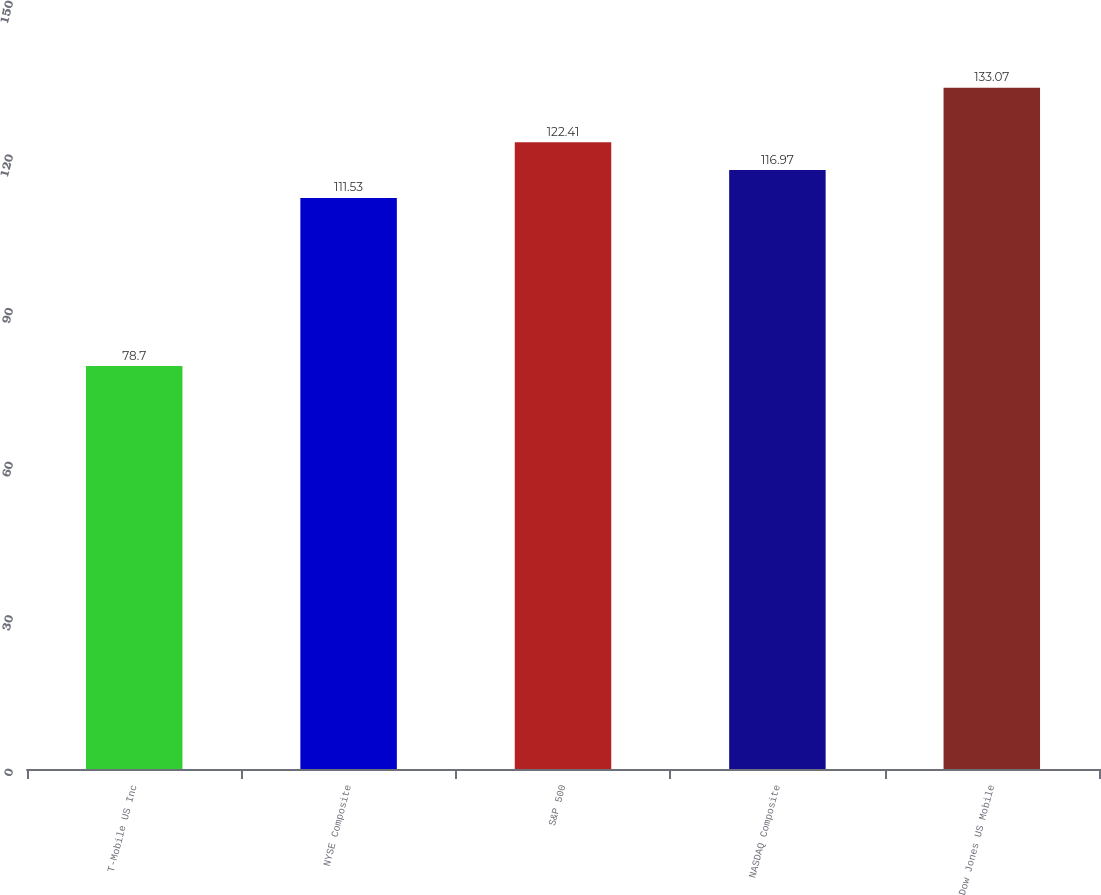Convert chart to OTSL. <chart><loc_0><loc_0><loc_500><loc_500><bar_chart><fcel>T-Mobile US Inc<fcel>NYSE Composite<fcel>S&P 500<fcel>NASDAQ Composite<fcel>Dow Jones US Mobile<nl><fcel>78.7<fcel>111.53<fcel>122.41<fcel>116.97<fcel>133.07<nl></chart> 